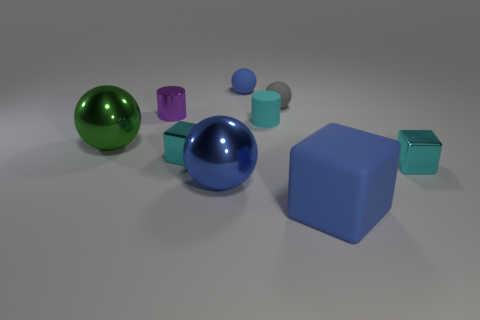What materials are the objects in the image made of, and how can you tell? The objects in the image appear to have varying materials. The shiny surfaces of the blue and green balls, as well as the smaller purple object, suggest that they could be made of a reflective material like metal or polished plastic due to their high gloss and clear reflections. The larger cyan object and the smaller aqua-colored objects have more matte finishes, implying they might be made of rubber or a similar non-reflective material. 